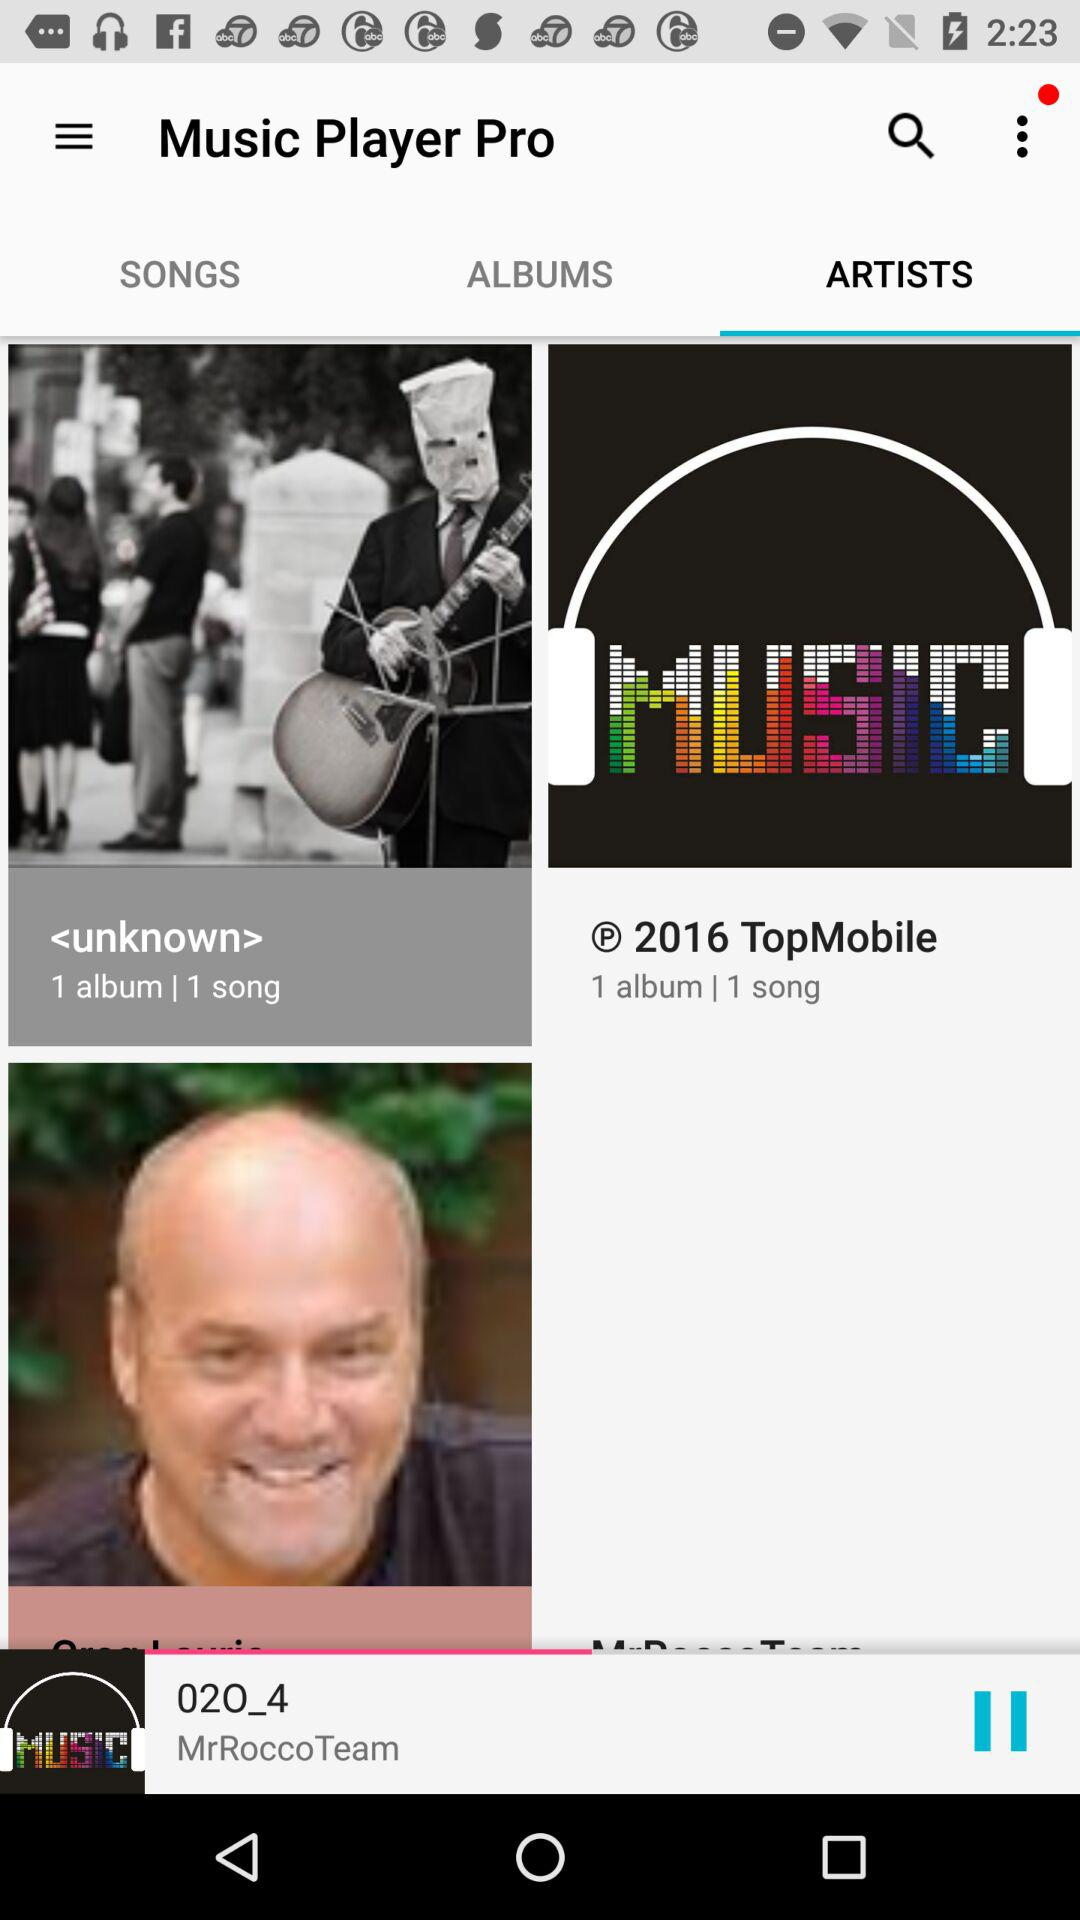Which audio is currently playing? The currently playing audio is "02O_4". 